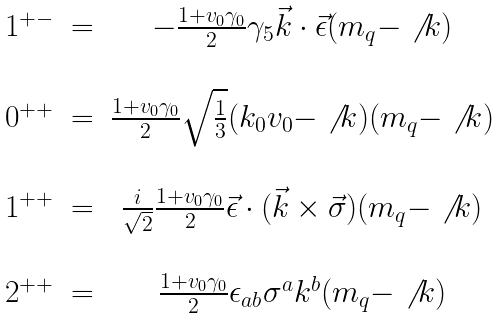Convert formula to latex. <formula><loc_0><loc_0><loc_500><loc_500>\begin{array} { c c c } 1 ^ { + - } & = & - \frac { 1 + v _ { 0 } \gamma _ { 0 } } { 2 } \gamma _ { 5 } \vec { k } \cdot \vec { \epsilon } ( m _ { q } - \not { \, k } ) \\ \\ 0 ^ { + + } & = & \frac { 1 + v _ { 0 } \gamma _ { 0 } } { 2 } \sqrt { \frac { 1 } { 3 } } ( k _ { 0 } v _ { 0 } - \not { \, k } ) ( m _ { q } - \not { \, k } ) \\ \\ 1 ^ { + + } & = & \frac { i } { \sqrt { 2 } } \frac { 1 + v _ { 0 } \gamma _ { 0 } } { 2 } \vec { \epsilon } \cdot ( \vec { k } \times \vec { \sigma } ) ( m _ { q } - \not { \, k } ) \\ \\ 2 ^ { + + } & = & \frac { 1 + v _ { 0 } \gamma _ { 0 } } { 2 } \epsilon _ { a b } \sigma ^ { a } k ^ { b } ( m _ { q } - \not { \, k } ) \\ \\ \end{array}</formula> 